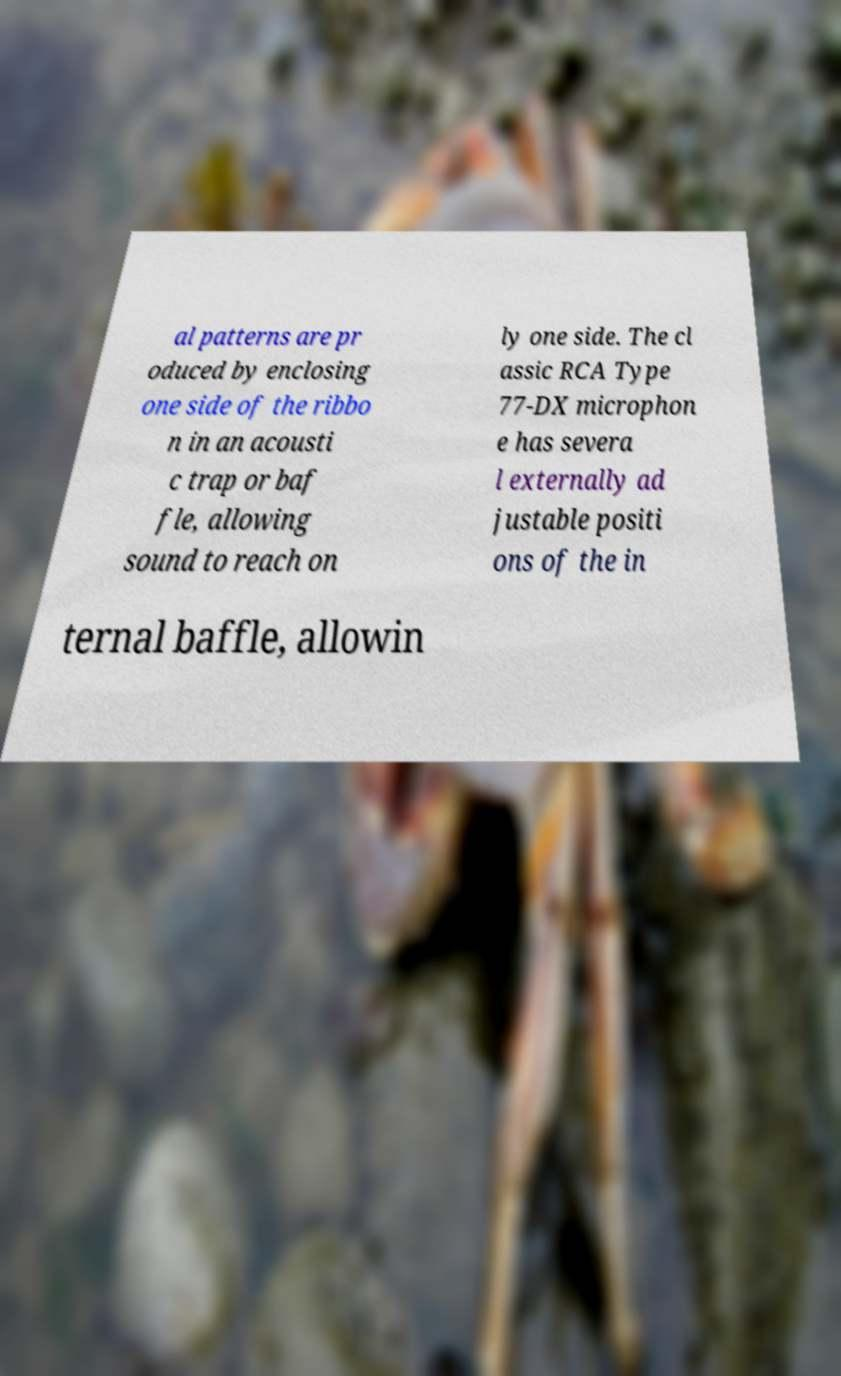Can you accurately transcribe the text from the provided image for me? al patterns are pr oduced by enclosing one side of the ribbo n in an acousti c trap or baf fle, allowing sound to reach on ly one side. The cl assic RCA Type 77-DX microphon e has severa l externally ad justable positi ons of the in ternal baffle, allowin 